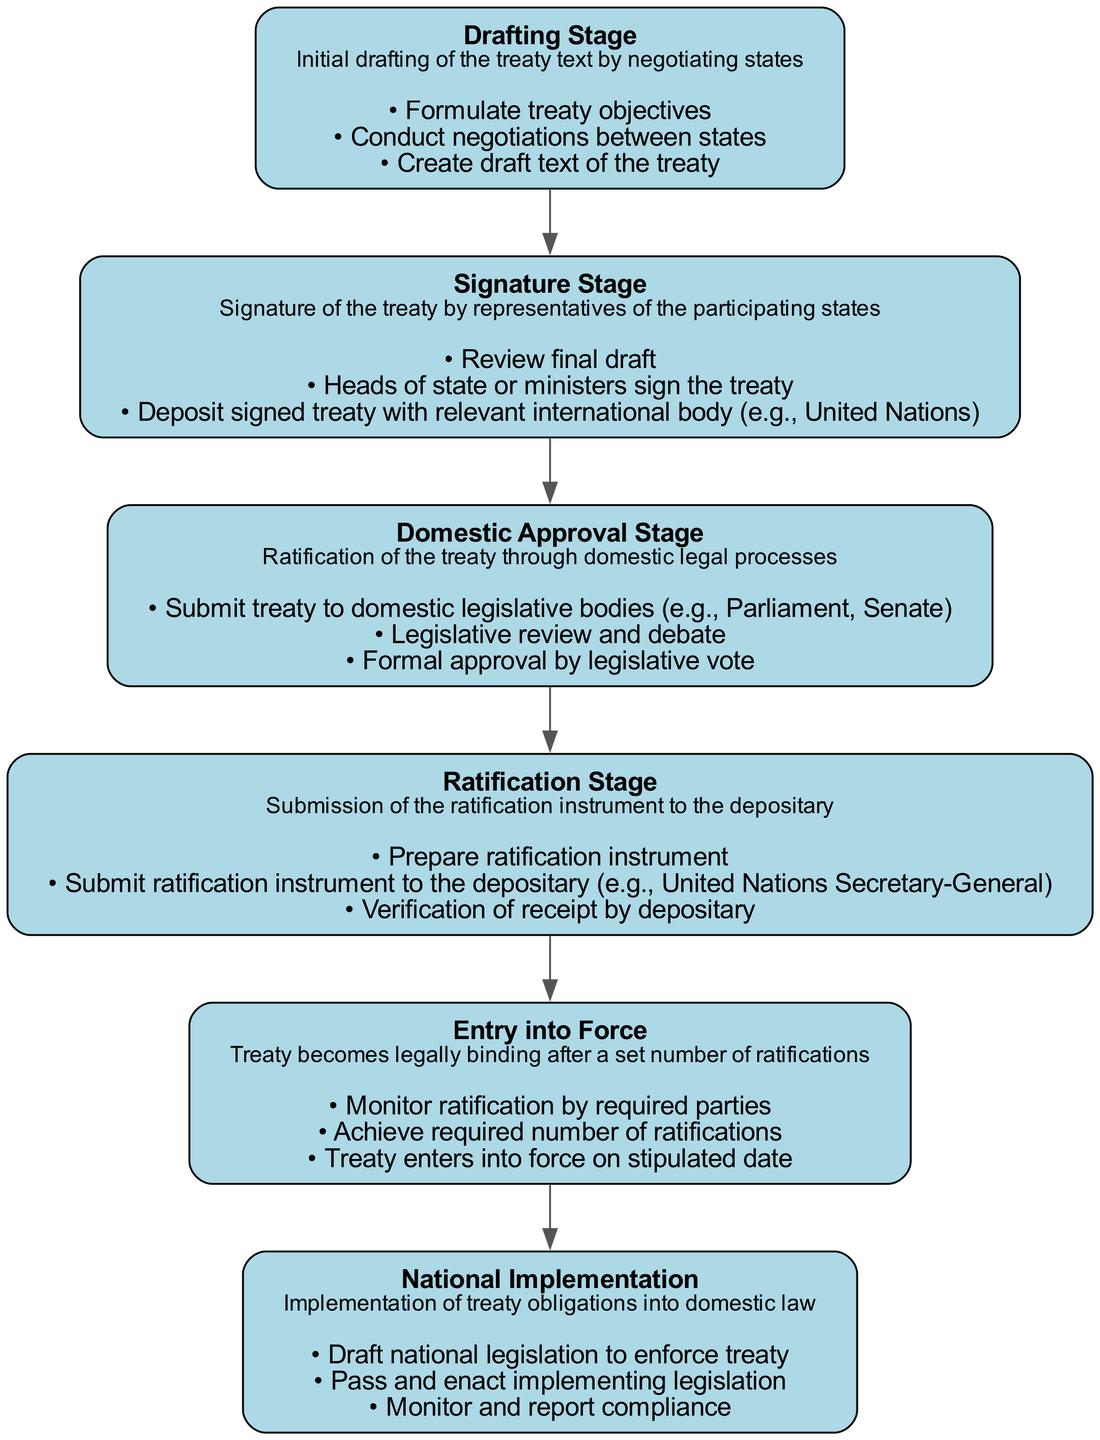What is the first stage in the treaty ratification process? The first stage listed in the diagram is the "Drafting Stage," which is where the initial drafting of the treaty text occurs.
Answer: Drafting Stage How many actions are involved in the Signature Stage? The "Signature Stage" has three specific actions outlined in the diagram: review final draft, heads of state or ministers sign the treaty, and deposit signed treaty with the relevant international body.
Answer: 3 What is required for the treaty to enter into force? According to the diagram, the treaty enters into force after achieving the required number of ratifications by the parties involved, as indicated in the "Entry into Force" stage.
Answer: Required number of ratifications What action follows the Domestic Approval Stage? After the "Domestic Approval Stage," which involves submitting the treaty to legislative bodies and obtaining approval, the next stage is the "Ratification Stage," where the ratification instrument is submitted.
Answer: Ratification Stage What is the main objective of the National Implementation stage? The "National Implementation" stage primarily focuses on drafting national legislation to enforce treaty obligations into domestic law and ensuring compliance with the treaty.
Answer: Enforce treaty obligations How many total stages are depicted in the diagram? The diagram consists of six distinct stages, starting from the Drafting Stage to National Implementation.
Answer: 6 During which stage do states formally approve the treaty? States formally approve the treaty during the "Domestic Approval Stage," which includes legislative review and formal voting.
Answer: Domestic Approval Stage Which action is performed at the end of the Ratification Stage? At the end of the "Ratification Stage," the action of verifying the receipt of the ratification instrument by the depositary is performed.
Answer: Verification of receipt What is the final stage of the treaty process? The final stage of the treaty process, as shown in the diagram, is "National Implementation," where participating states implement the treaty's obligations into their domestic law.
Answer: National Implementation 